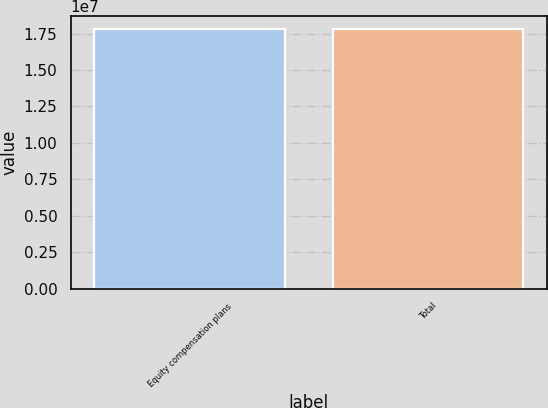Convert chart. <chart><loc_0><loc_0><loc_500><loc_500><bar_chart><fcel>Equity compensation plans<fcel>Total<nl><fcel>1.77984e+07<fcel>1.77984e+07<nl></chart> 